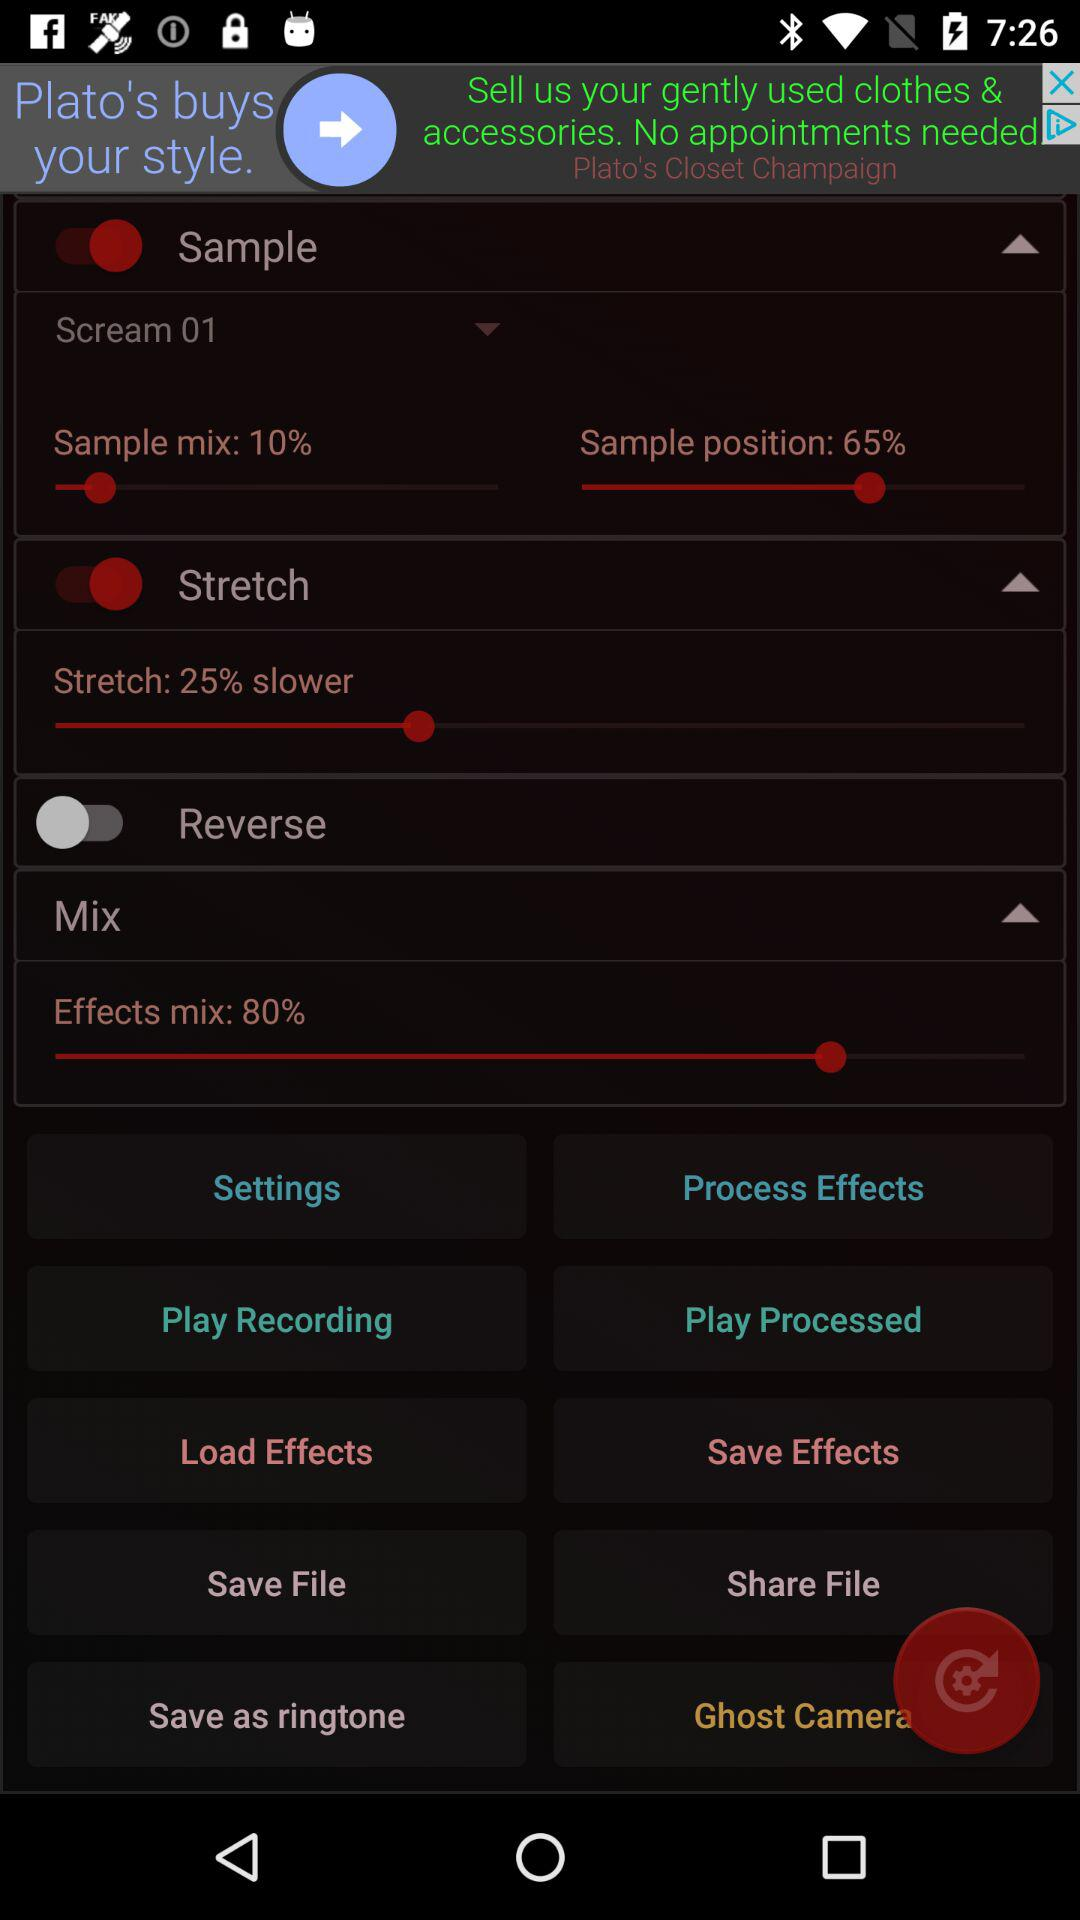What is the set percentage of "Sample position"? The set percentage is 65. 